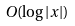<formula> <loc_0><loc_0><loc_500><loc_500>O ( \log | x | )</formula> 